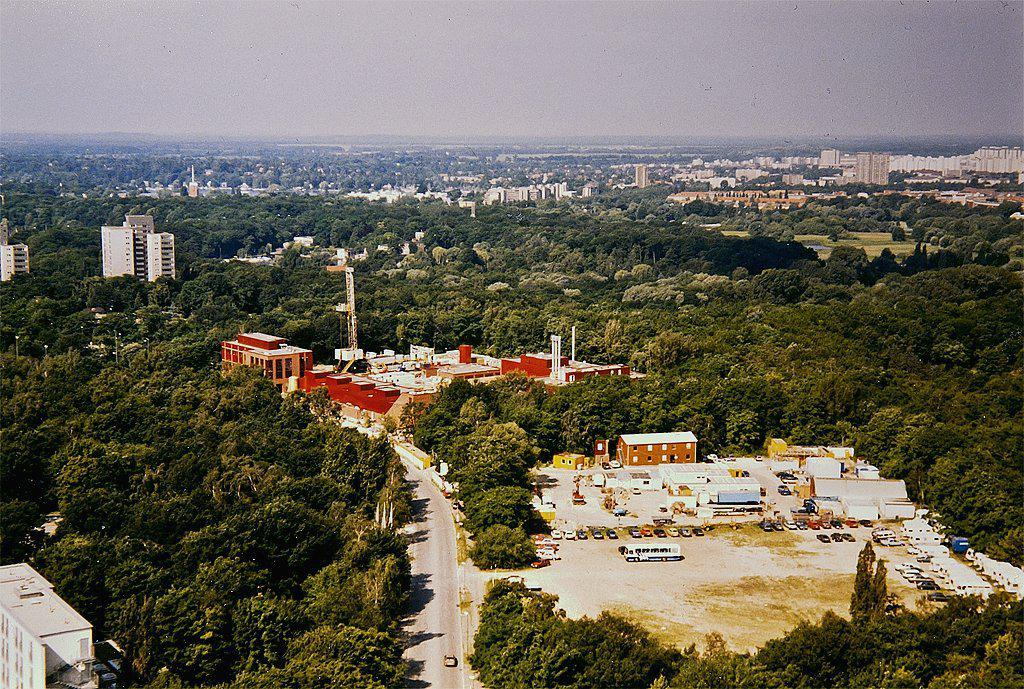What type of structures can be seen in the image? There are buildings in the image. What other natural elements are present in the image? There are trees in the image. What type of pathway is visible in the image? There is a road in the image. What are the tall, thin objects in the image? There are poles in the image. What type of transportation is present in the image? There are vehicles in the image. What stands out as a tall, prominent structure in the image? There is a tower in the image. What can be seen in the background of the image? The sky is visible in the background of the image. Where is the shelf located in the image? There is no shelf present in the image. What type of jewel is being cooked in the stew in the image? There is no stew or jewel present in the image. 